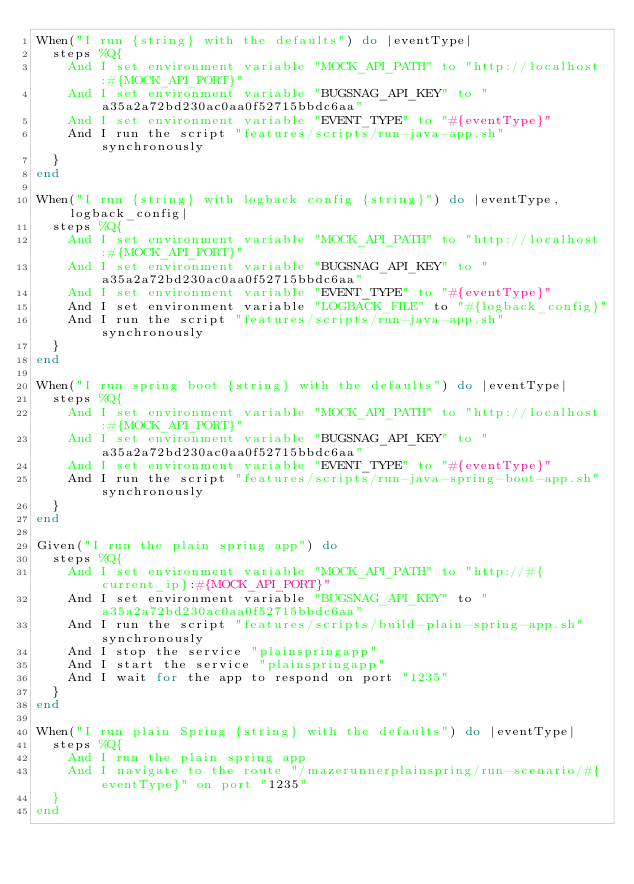<code> <loc_0><loc_0><loc_500><loc_500><_Ruby_>When("I run {string} with the defaults") do |eventType|
  steps %Q{
    And I set environment variable "MOCK_API_PATH" to "http://localhost:#{MOCK_API_PORT}"
    And I set environment variable "BUGSNAG_API_KEY" to "a35a2a72bd230ac0aa0f52715bbdc6aa"
    And I set environment variable "EVENT_TYPE" to "#{eventType}"
    And I run the script "features/scripts/run-java-app.sh" synchronously
  }
end

When("I run {string} with logback config {string}") do |eventType, logback_config|
  steps %Q{
    And I set environment variable "MOCK_API_PATH" to "http://localhost:#{MOCK_API_PORT}"
    And I set environment variable "BUGSNAG_API_KEY" to "a35a2a72bd230ac0aa0f52715bbdc6aa"
    And I set environment variable "EVENT_TYPE" to "#{eventType}"
    And I set environment variable "LOGBACK_FILE" to "#{logback_config}"
    And I run the script "features/scripts/run-java-app.sh" synchronously
  }
end

When("I run spring boot {string} with the defaults") do |eventType|
  steps %Q{
    And I set environment variable "MOCK_API_PATH" to "http://localhost:#{MOCK_API_PORT}"
    And I set environment variable "BUGSNAG_API_KEY" to "a35a2a72bd230ac0aa0f52715bbdc6aa"
    And I set environment variable "EVENT_TYPE" to "#{eventType}"
    And I run the script "features/scripts/run-java-spring-boot-app.sh" synchronously
  }
end

Given("I run the plain spring app") do
  steps %Q{
    And I set environment variable "MOCK_API_PATH" to "http://#{current_ip}:#{MOCK_API_PORT}"
    And I set environment variable "BUGSNAG_API_KEY" to "a35a2a72bd230ac0aa0f52715bbdc6aa"
    And I run the script "features/scripts/build-plain-spring-app.sh" synchronously
    And I stop the service "plainspringapp"
    And I start the service "plainspringapp"
    And I wait for the app to respond on port "1235"
  }
end

When("I run plain Spring {string} with the defaults") do |eventType|
  steps %Q{
    And I run the plain spring app
    And I navigate to the route "/mazerunnerplainspring/run-scenario/#{eventType}" on port "1235"
  }
end

</code> 